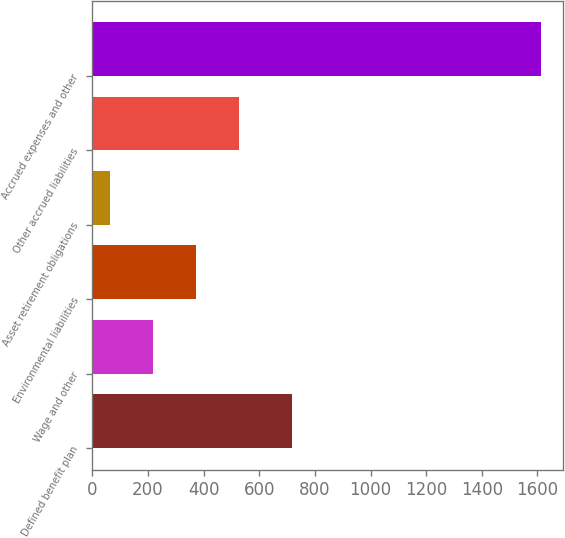<chart> <loc_0><loc_0><loc_500><loc_500><bar_chart><fcel>Defined benefit plan<fcel>Wage and other<fcel>Environmental liabilities<fcel>Asset retirement obligations<fcel>Other accrued liabilities<fcel>Accrued expenses and other<nl><fcel>719<fcel>218.7<fcel>373.4<fcel>64<fcel>528.1<fcel>1611<nl></chart> 